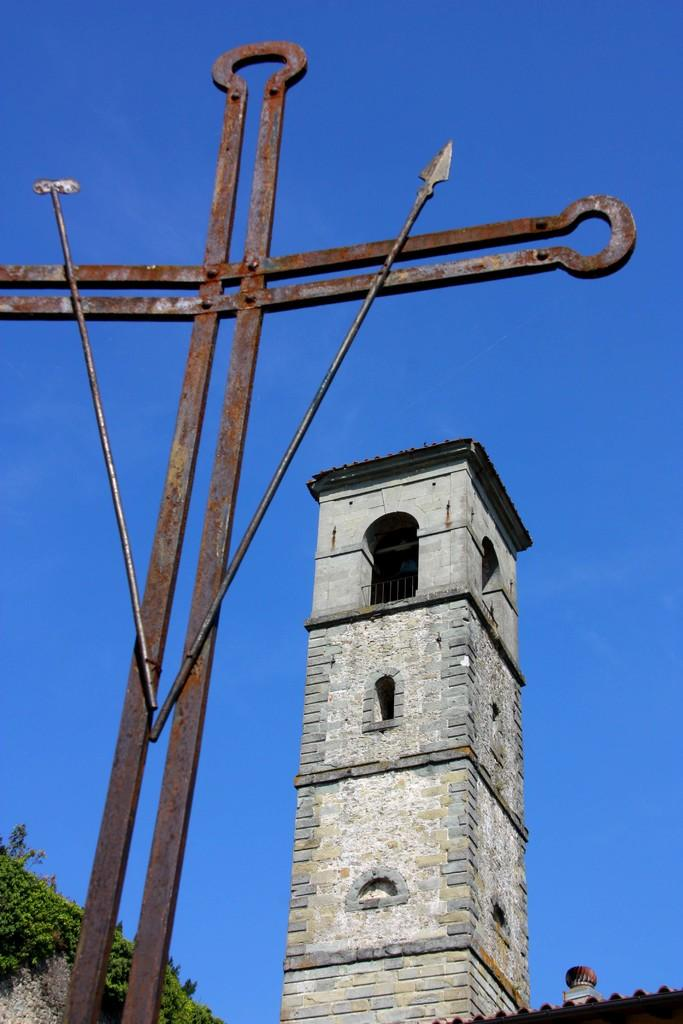What type of material is used for the wall of the building in the image? The building has a brick wall. What architectural feature can be seen on the building? The building has an arch. What safety feature is present on the building? The building has a railing. What type of cross is visible in the image? There is a cross made of iron rods. What type of vegetation is on the left side of the image? There are plants on the left side of the image. What is visible in the background of the image? The sky is visible in the background of the image. What type of lettuce is growing on the right side of the image? There is no lettuce present in the image; it features a building with plants on the left side. Can you describe the fragrance of the rose in the image? There is no rose present in the image; it features a building with plants on the left side. 